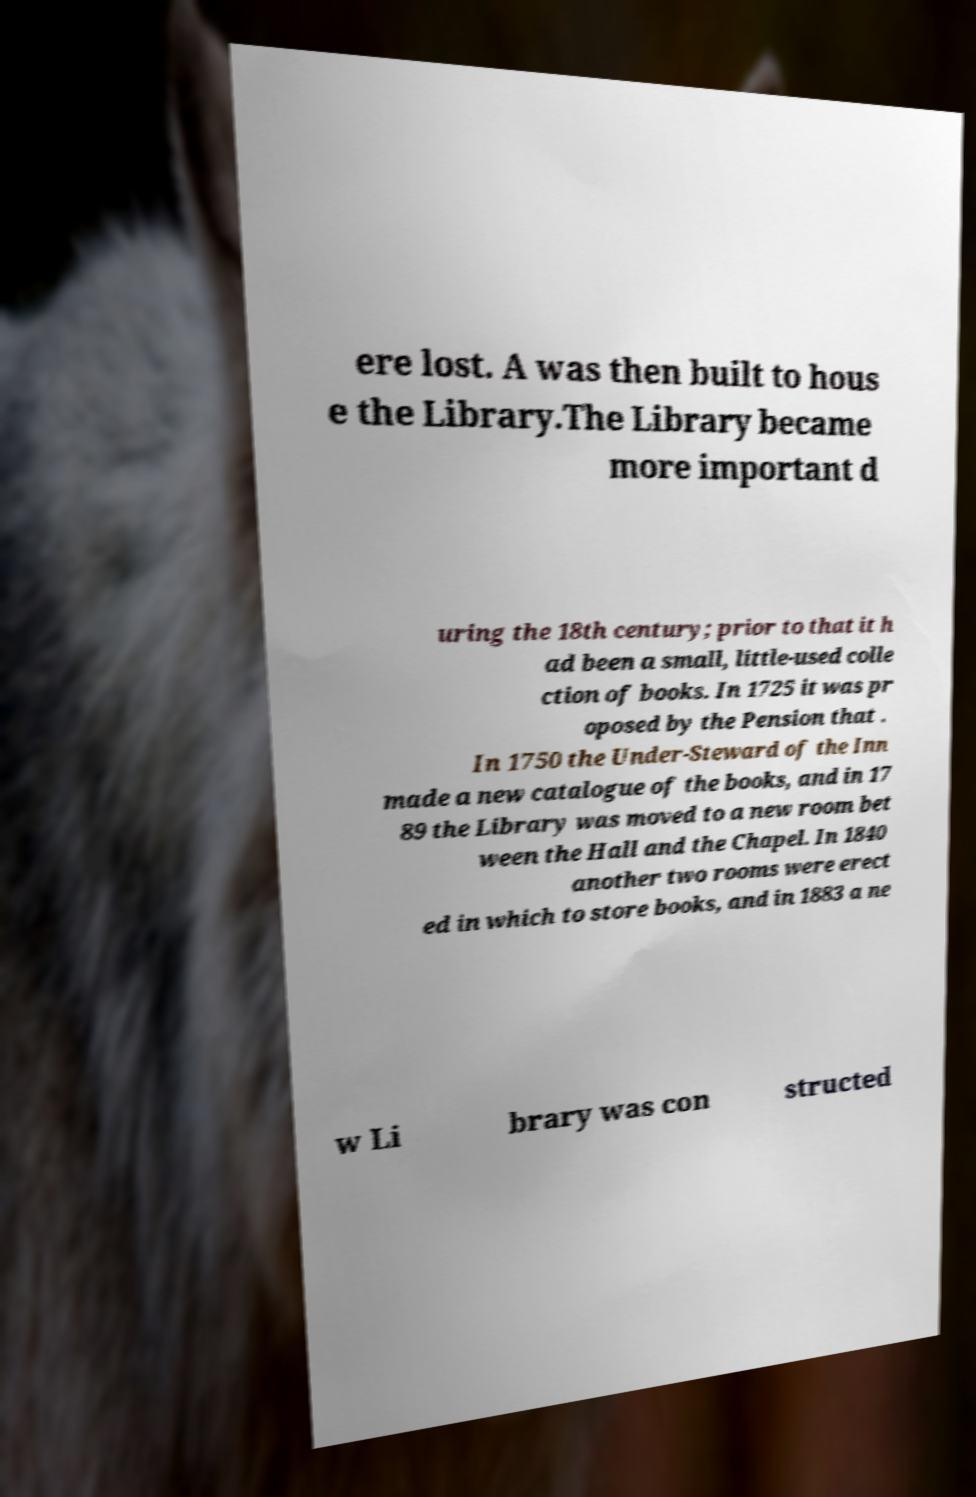There's text embedded in this image that I need extracted. Can you transcribe it verbatim? ere lost. A was then built to hous e the Library.The Library became more important d uring the 18th century; prior to that it h ad been a small, little-used colle ction of books. In 1725 it was pr oposed by the Pension that . In 1750 the Under-Steward of the Inn made a new catalogue of the books, and in 17 89 the Library was moved to a new room bet ween the Hall and the Chapel. In 1840 another two rooms were erect ed in which to store books, and in 1883 a ne w Li brary was con structed 